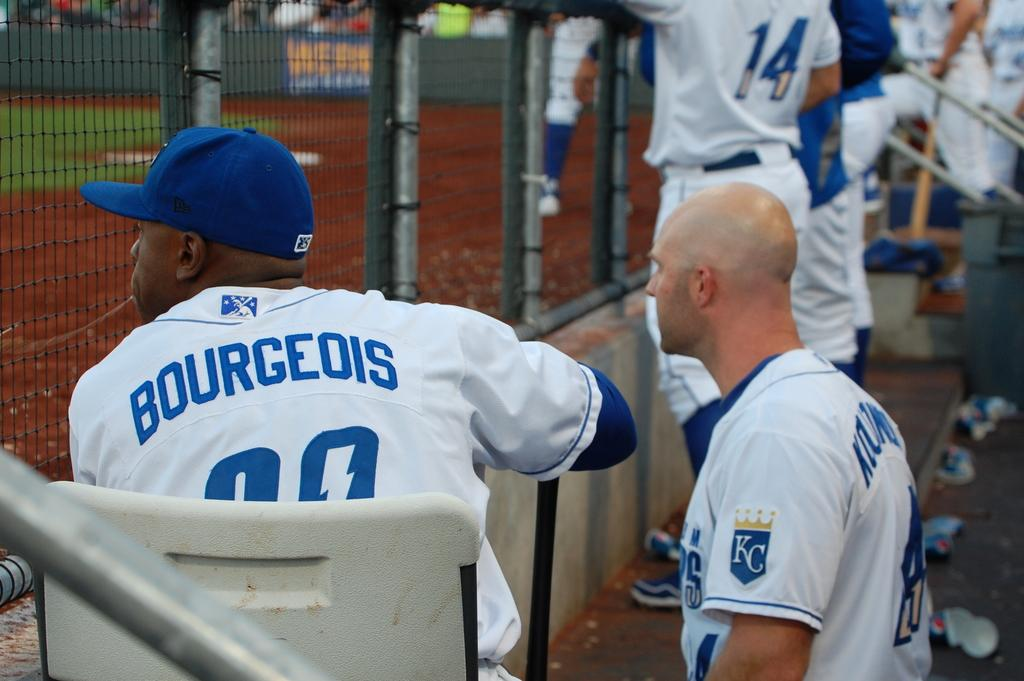<image>
Give a short and clear explanation of the subsequent image. baseball players in a dugout and one is wearing a jersey reading Bourgeois 